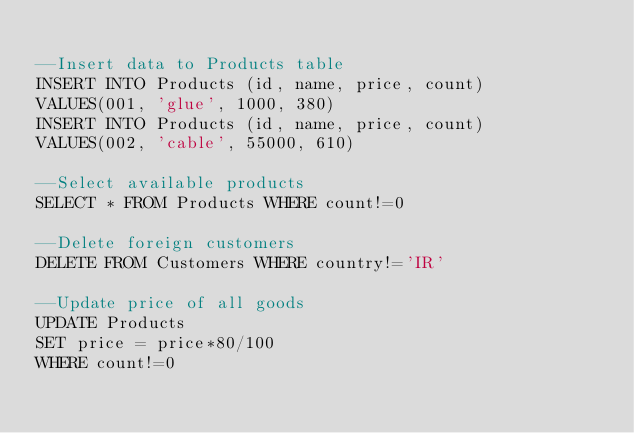Convert code to text. <code><loc_0><loc_0><loc_500><loc_500><_SQL_>
--Insert data to Products table
INSERT INTO Products (id, name, price, count)
VALUES(001, 'glue', 1000, 380)
INSERT INTO Products (id, name, price, count)
VALUES(002, 'cable', 55000, 610)

--Select available products
SELECT * FROM Products WHERE count!=0

--Delete foreign customers
DELETE FROM Customers WHERE country!='IR'

--Update price of all goods
UPDATE Products
SET price = price*80/100
WHERE count!=0
</code> 